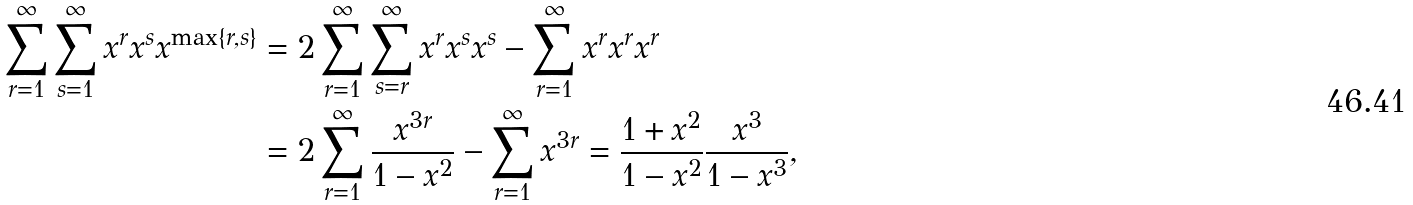Convert formula to latex. <formula><loc_0><loc_0><loc_500><loc_500>\sum _ { r = 1 } ^ { \infty } \sum _ { s = 1 } ^ { \infty } x ^ { r } x ^ { s } x ^ { \max \{ r , s \} } & = 2 \sum _ { r = 1 } ^ { \infty } \sum _ { s = r } ^ { \infty } x ^ { r } x ^ { s } x ^ { s } - \sum _ { r = 1 } ^ { \infty } x ^ { r } x ^ { r } x ^ { r } \\ & = 2 \sum _ { r = 1 } ^ { \infty } \frac { x ^ { 3 r } } { 1 - x ^ { 2 } } - \sum _ { r = 1 } ^ { \infty } x ^ { 3 r } = \frac { 1 + x ^ { 2 } } { 1 - x ^ { 2 } } \frac { x ^ { 3 } } { 1 - x ^ { 3 } } ,</formula> 